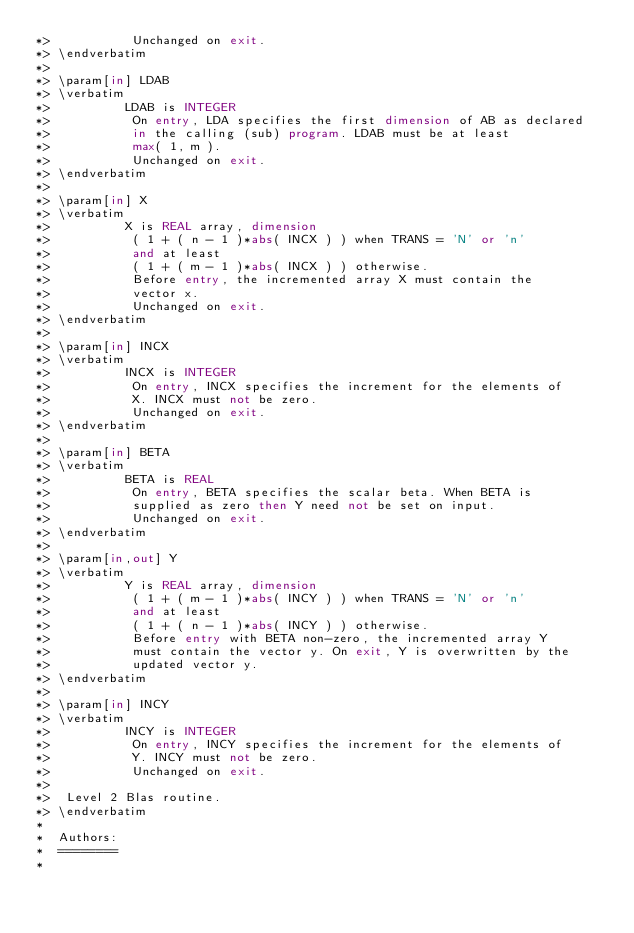Convert code to text. <code><loc_0><loc_0><loc_500><loc_500><_FORTRAN_>*>           Unchanged on exit.
*> \endverbatim
*>
*> \param[in] LDAB
*> \verbatim
*>          LDAB is INTEGER
*>           On entry, LDA specifies the first dimension of AB as declared
*>           in the calling (sub) program. LDAB must be at least
*>           max( 1, m ).
*>           Unchanged on exit.
*> \endverbatim
*>
*> \param[in] X
*> \verbatim
*>          X is REAL array, dimension
*>           ( 1 + ( n - 1 )*abs( INCX ) ) when TRANS = 'N' or 'n'
*>           and at least
*>           ( 1 + ( m - 1 )*abs( INCX ) ) otherwise.
*>           Before entry, the incremented array X must contain the
*>           vector x.
*>           Unchanged on exit.
*> \endverbatim
*>
*> \param[in] INCX
*> \verbatim
*>          INCX is INTEGER
*>           On entry, INCX specifies the increment for the elements of
*>           X. INCX must not be zero.
*>           Unchanged on exit.
*> \endverbatim
*>
*> \param[in] BETA
*> \verbatim
*>          BETA is REAL
*>           On entry, BETA specifies the scalar beta. When BETA is
*>           supplied as zero then Y need not be set on input.
*>           Unchanged on exit.
*> \endverbatim
*>
*> \param[in,out] Y
*> \verbatim
*>          Y is REAL array, dimension
*>           ( 1 + ( m - 1 )*abs( INCY ) ) when TRANS = 'N' or 'n'
*>           and at least
*>           ( 1 + ( n - 1 )*abs( INCY ) ) otherwise.
*>           Before entry with BETA non-zero, the incremented array Y
*>           must contain the vector y. On exit, Y is overwritten by the
*>           updated vector y.
*> \endverbatim
*>
*> \param[in] INCY
*> \verbatim
*>          INCY is INTEGER
*>           On entry, INCY specifies the increment for the elements of
*>           Y. INCY must not be zero.
*>           Unchanged on exit.
*>
*>  Level 2 Blas routine.
*> \endverbatim
*
*  Authors:
*  ========
*</code> 